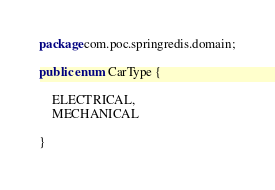<code> <loc_0><loc_0><loc_500><loc_500><_Java_>package com.poc.springredis.domain;

public enum CarType {

    ELECTRICAL,
    MECHANICAL

}
</code> 